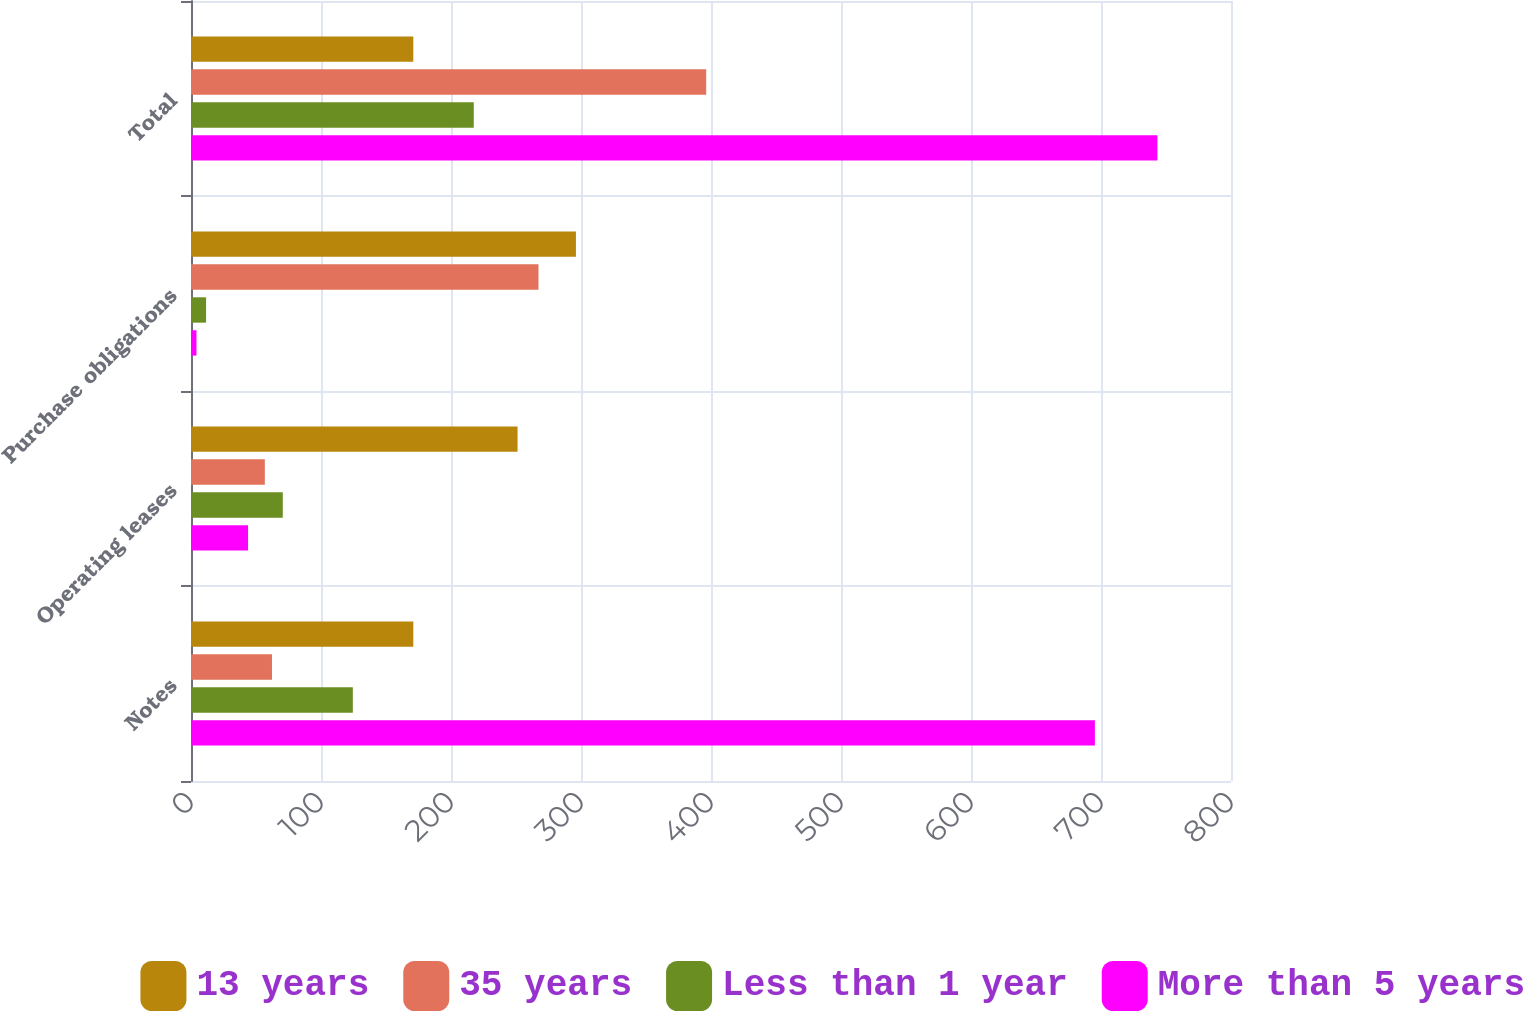Convert chart to OTSL. <chart><loc_0><loc_0><loc_500><loc_500><stacked_bar_chart><ecel><fcel>Notes<fcel>Operating leases<fcel>Purchase obligations<fcel>Total<nl><fcel>13 years<fcel>171<fcel>251.2<fcel>296.1<fcel>171<nl><fcel>35 years<fcel>62.3<fcel>56.8<fcel>267.3<fcel>396.3<nl><fcel>Less than 1 year<fcel>124.5<fcel>70.6<fcel>11.6<fcel>217.5<nl><fcel>More than 5 years<fcel>695.3<fcel>43.9<fcel>4.2<fcel>743.4<nl></chart> 